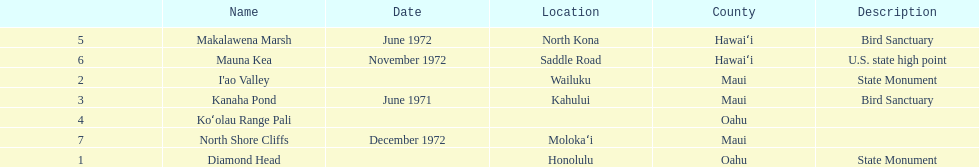How many images are listed? 6. 